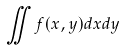Convert formula to latex. <formula><loc_0><loc_0><loc_500><loc_500>\iint f ( x , y ) d x d y</formula> 